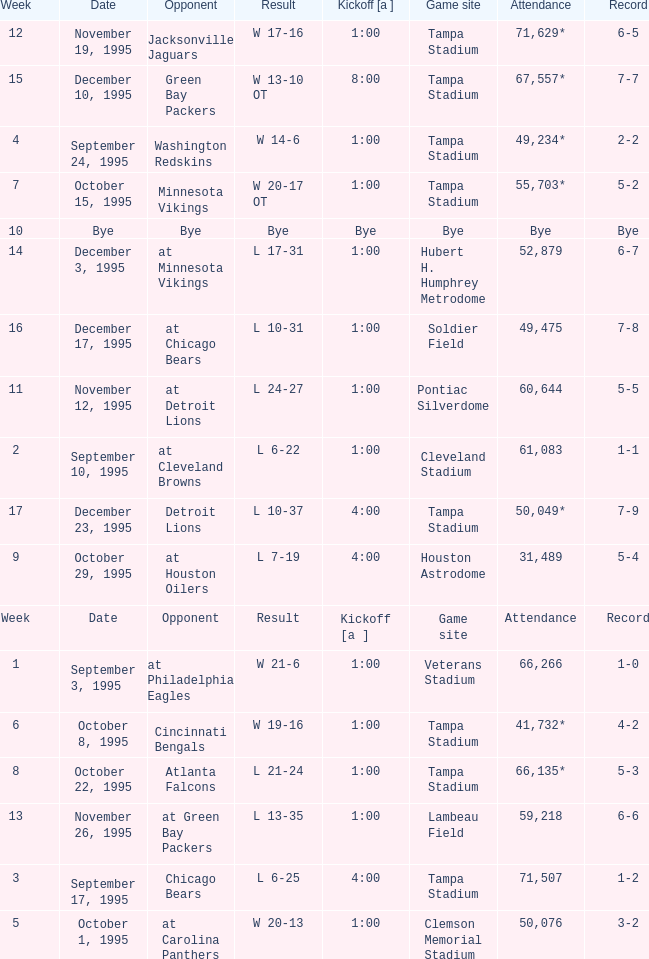On what date was Tampa Bay's Week 4 game? September 24, 1995. 